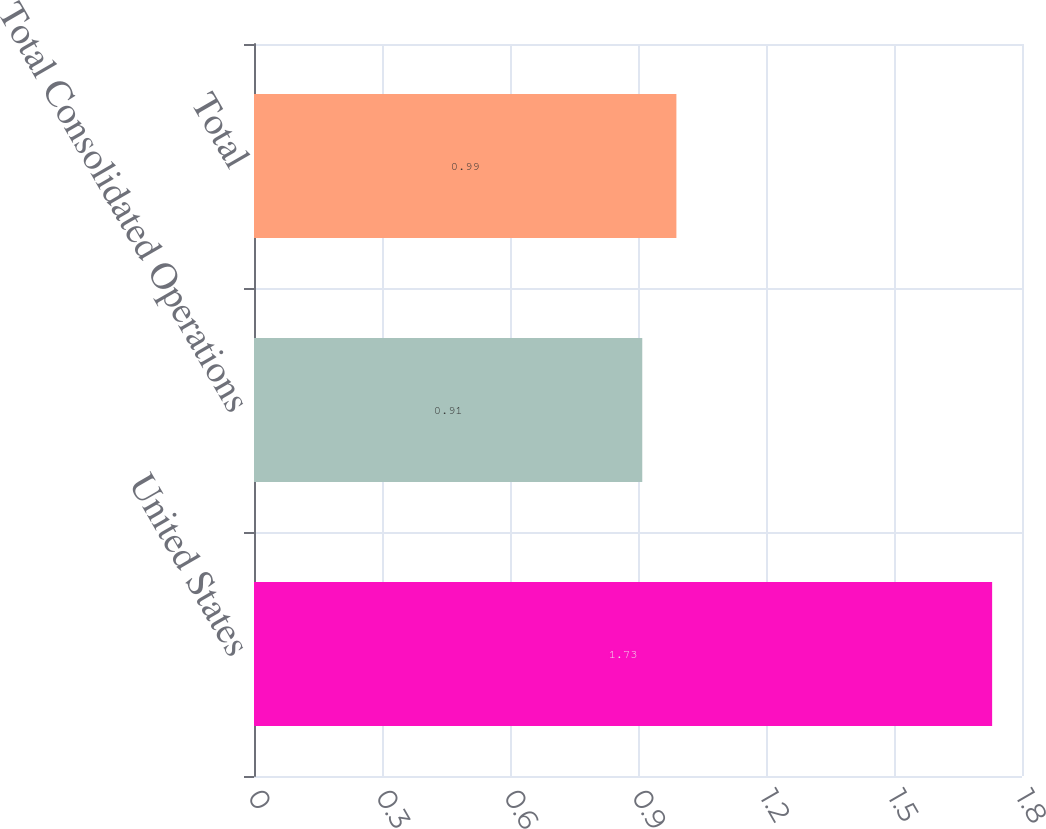Convert chart. <chart><loc_0><loc_0><loc_500><loc_500><bar_chart><fcel>United States<fcel>Total Consolidated Operations<fcel>Total<nl><fcel>1.73<fcel>0.91<fcel>0.99<nl></chart> 